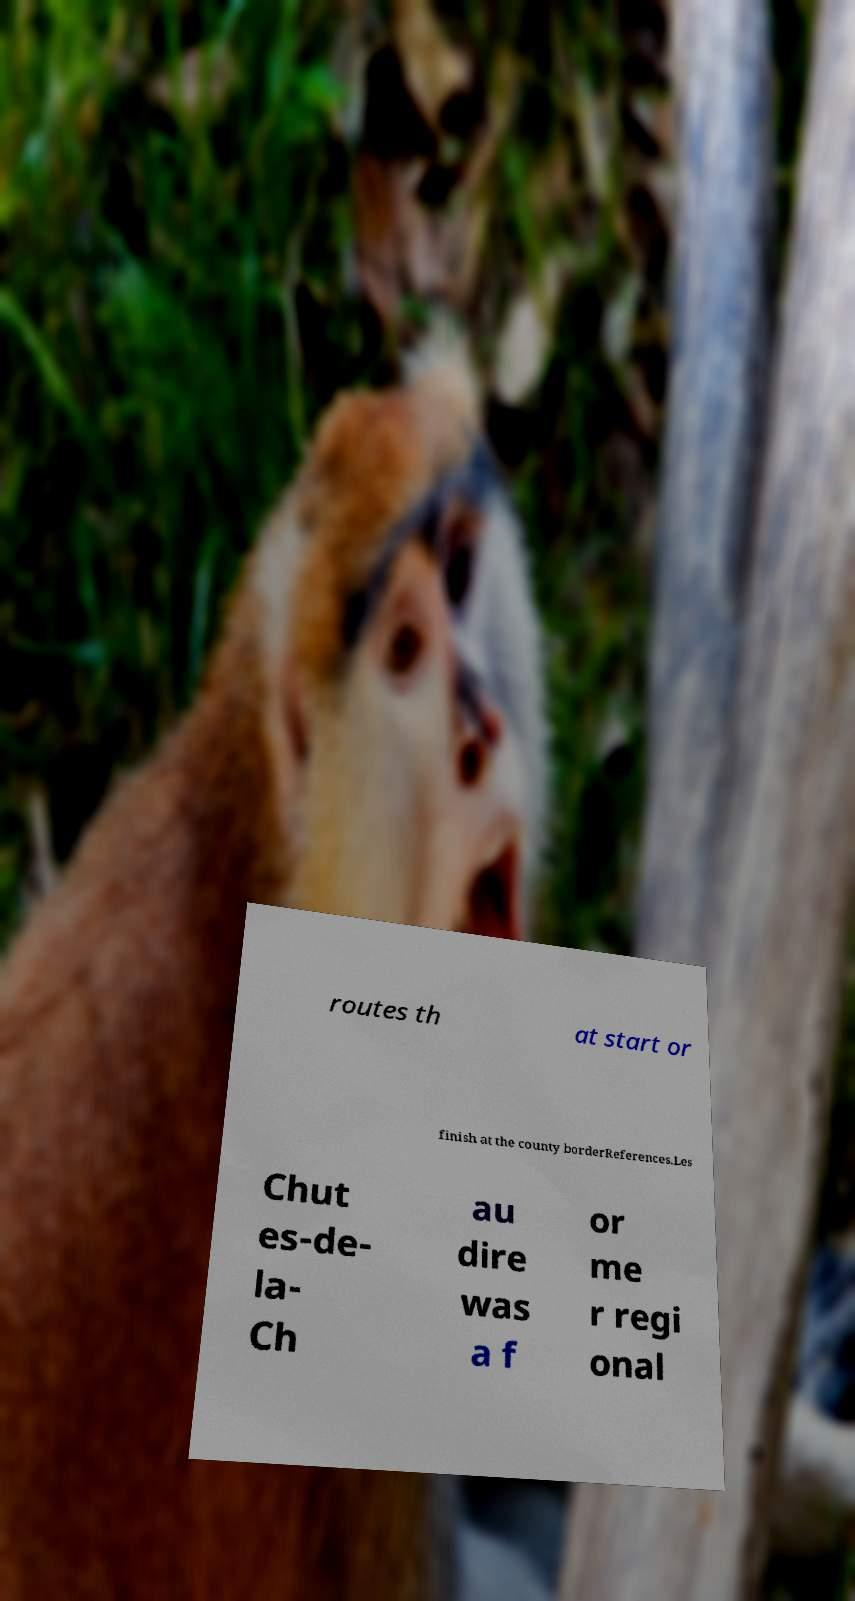There's text embedded in this image that I need extracted. Can you transcribe it verbatim? routes th at start or finish at the county borderReferences.Les Chut es-de- la- Ch au dire was a f or me r regi onal 